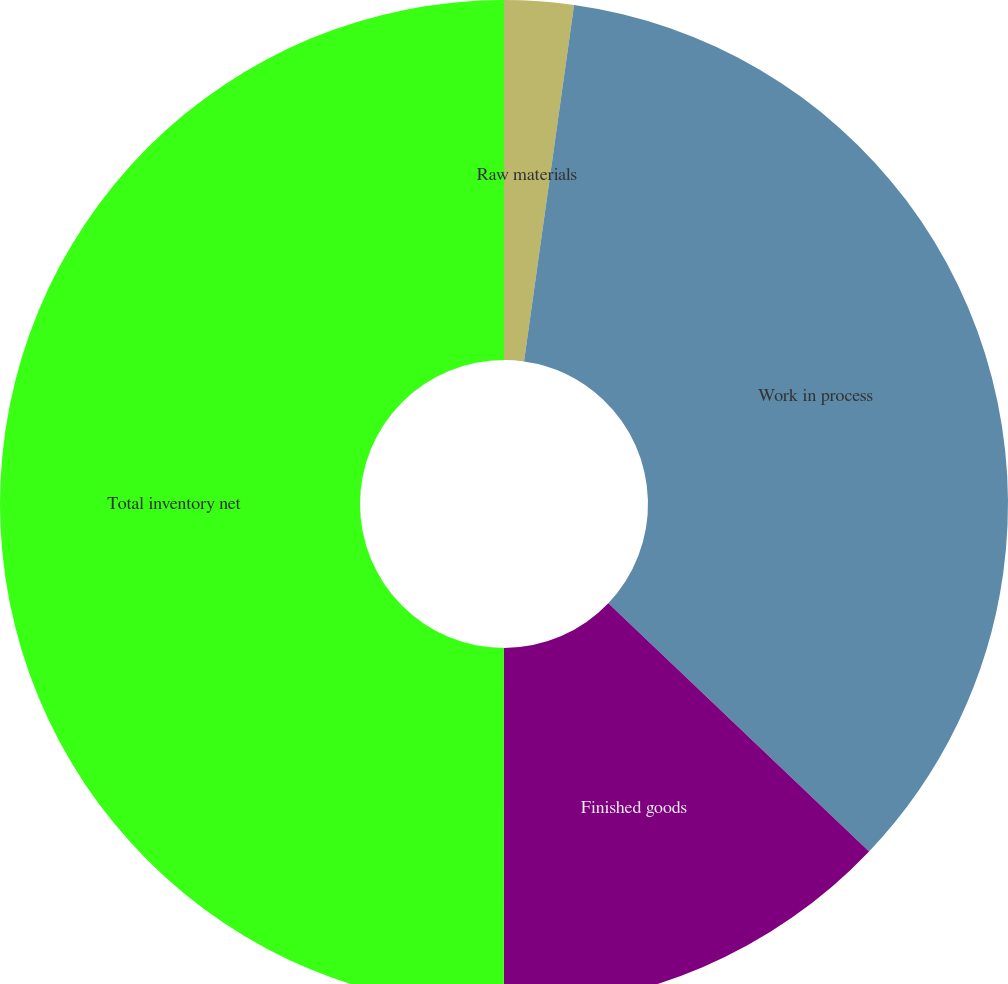Convert chart to OTSL. <chart><loc_0><loc_0><loc_500><loc_500><pie_chart><fcel>Raw materials<fcel>Work in process<fcel>Finished goods<fcel>Total inventory net<nl><fcel>2.22%<fcel>34.89%<fcel>12.9%<fcel>50.0%<nl></chart> 